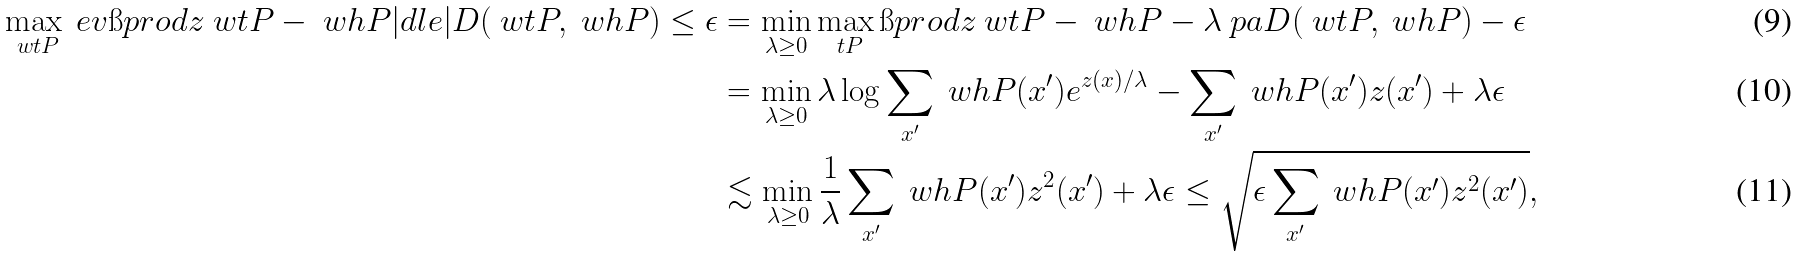<formula> <loc_0><loc_0><loc_500><loc_500>\max _ { \ w t { P } } \ e v { \i p r o d { z } { \ w t { P } - \ w h { P } } | d l e | D ( \ w t { P } , \ w h { P } ) \leq \epsilon } & = \min _ { \lambda \geq 0 } \max _ { \ t P } \i p r o d { z } { \ w t { P } - \ w h { P } } - \lambda \ p a { D ( \ w t { P } , \ w h { P } ) - \epsilon } \\ & = \min _ { \lambda \geq 0 } \lambda \log \sum _ { x ^ { \prime } } \ w h { P } ( x ^ { \prime } ) e ^ { z ( x ) / \lambda } - \sum _ { x ^ { \prime } } \ w h { P } ( x ^ { \prime } ) z ( x ^ { \prime } ) + \lambda \epsilon \\ & \lesssim \min _ { \lambda \geq 0 } \frac { 1 } { \lambda } \sum _ { x ^ { \prime } } \ w h { P } ( x ^ { \prime } ) z ^ { 2 } ( x ^ { \prime } ) + \lambda \epsilon \leq \sqrt { \epsilon \sum _ { x ^ { \prime } } \ w h { P } ( x ^ { \prime } ) z ^ { 2 } ( x ^ { \prime } ) } ,</formula> 